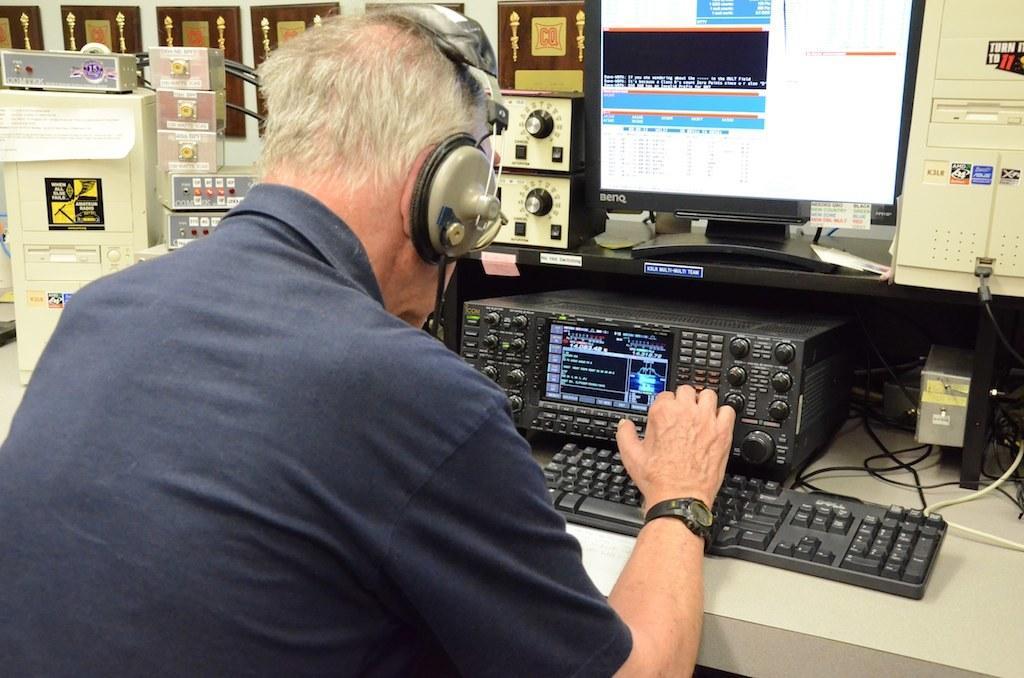Can you describe this image briefly? On the left side, there is a person in a shirt, wearing a headset and operating a computer. In front of him, there is a keyboard, an equalizer, a monitor and other devices arranged on the shelves. In the background, there are photo frames attached to a white wall. 